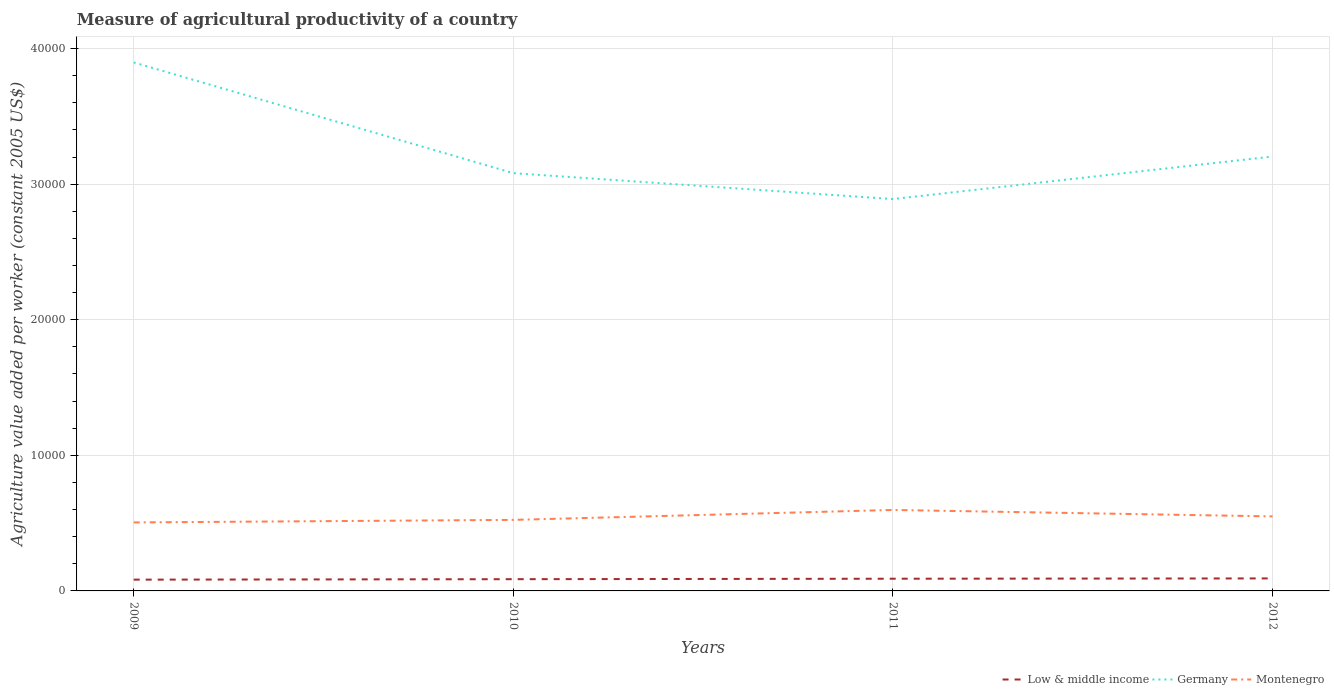How many different coloured lines are there?
Your answer should be compact. 3. Does the line corresponding to Montenegro intersect with the line corresponding to Low & middle income?
Ensure brevity in your answer.  No. Is the number of lines equal to the number of legend labels?
Your answer should be compact. Yes. Across all years, what is the maximum measure of agricultural productivity in Montenegro?
Offer a terse response. 5051.79. In which year was the measure of agricultural productivity in Germany maximum?
Keep it short and to the point. 2011. What is the total measure of agricultural productivity in Germany in the graph?
Ensure brevity in your answer.  -3137.17. What is the difference between the highest and the second highest measure of agricultural productivity in Montenegro?
Your answer should be compact. 919.67. How many years are there in the graph?
Your response must be concise. 4. What is the difference between two consecutive major ticks on the Y-axis?
Offer a terse response. 10000. Are the values on the major ticks of Y-axis written in scientific E-notation?
Offer a terse response. No. How are the legend labels stacked?
Your response must be concise. Horizontal. What is the title of the graph?
Offer a very short reply. Measure of agricultural productivity of a country. What is the label or title of the X-axis?
Ensure brevity in your answer.  Years. What is the label or title of the Y-axis?
Make the answer very short. Agriculture value added per worker (constant 2005 US$). What is the Agriculture value added per worker (constant 2005 US$) of Low & middle income in 2009?
Provide a succinct answer. 832.07. What is the Agriculture value added per worker (constant 2005 US$) of Germany in 2009?
Your answer should be compact. 3.90e+04. What is the Agriculture value added per worker (constant 2005 US$) in Montenegro in 2009?
Ensure brevity in your answer.  5051.79. What is the Agriculture value added per worker (constant 2005 US$) in Low & middle income in 2010?
Offer a terse response. 865.64. What is the Agriculture value added per worker (constant 2005 US$) in Germany in 2010?
Your answer should be very brief. 3.08e+04. What is the Agriculture value added per worker (constant 2005 US$) of Montenegro in 2010?
Give a very brief answer. 5239.42. What is the Agriculture value added per worker (constant 2005 US$) of Low & middle income in 2011?
Offer a terse response. 900.08. What is the Agriculture value added per worker (constant 2005 US$) of Germany in 2011?
Offer a terse response. 2.89e+04. What is the Agriculture value added per worker (constant 2005 US$) of Montenegro in 2011?
Provide a succinct answer. 5971.47. What is the Agriculture value added per worker (constant 2005 US$) in Low & middle income in 2012?
Your response must be concise. 922.36. What is the Agriculture value added per worker (constant 2005 US$) in Germany in 2012?
Offer a terse response. 3.20e+04. What is the Agriculture value added per worker (constant 2005 US$) of Montenegro in 2012?
Keep it short and to the point. 5496.22. Across all years, what is the maximum Agriculture value added per worker (constant 2005 US$) of Low & middle income?
Ensure brevity in your answer.  922.36. Across all years, what is the maximum Agriculture value added per worker (constant 2005 US$) in Germany?
Provide a succinct answer. 3.90e+04. Across all years, what is the maximum Agriculture value added per worker (constant 2005 US$) of Montenegro?
Your answer should be compact. 5971.47. Across all years, what is the minimum Agriculture value added per worker (constant 2005 US$) in Low & middle income?
Your answer should be very brief. 832.07. Across all years, what is the minimum Agriculture value added per worker (constant 2005 US$) of Germany?
Offer a very short reply. 2.89e+04. Across all years, what is the minimum Agriculture value added per worker (constant 2005 US$) of Montenegro?
Provide a short and direct response. 5051.79. What is the total Agriculture value added per worker (constant 2005 US$) of Low & middle income in the graph?
Give a very brief answer. 3520.15. What is the total Agriculture value added per worker (constant 2005 US$) of Germany in the graph?
Make the answer very short. 1.31e+05. What is the total Agriculture value added per worker (constant 2005 US$) in Montenegro in the graph?
Your response must be concise. 2.18e+04. What is the difference between the Agriculture value added per worker (constant 2005 US$) of Low & middle income in 2009 and that in 2010?
Your answer should be compact. -33.57. What is the difference between the Agriculture value added per worker (constant 2005 US$) in Germany in 2009 and that in 2010?
Offer a terse response. 8165.24. What is the difference between the Agriculture value added per worker (constant 2005 US$) in Montenegro in 2009 and that in 2010?
Your answer should be very brief. -187.63. What is the difference between the Agriculture value added per worker (constant 2005 US$) of Low & middle income in 2009 and that in 2011?
Ensure brevity in your answer.  -68.01. What is the difference between the Agriculture value added per worker (constant 2005 US$) in Germany in 2009 and that in 2011?
Provide a succinct answer. 1.01e+04. What is the difference between the Agriculture value added per worker (constant 2005 US$) of Montenegro in 2009 and that in 2011?
Give a very brief answer. -919.67. What is the difference between the Agriculture value added per worker (constant 2005 US$) in Low & middle income in 2009 and that in 2012?
Your response must be concise. -90.29. What is the difference between the Agriculture value added per worker (constant 2005 US$) of Germany in 2009 and that in 2012?
Offer a terse response. 6940.03. What is the difference between the Agriculture value added per worker (constant 2005 US$) of Montenegro in 2009 and that in 2012?
Ensure brevity in your answer.  -444.42. What is the difference between the Agriculture value added per worker (constant 2005 US$) of Low & middle income in 2010 and that in 2011?
Your answer should be compact. -34.44. What is the difference between the Agriculture value added per worker (constant 2005 US$) of Germany in 2010 and that in 2011?
Give a very brief answer. 1911.97. What is the difference between the Agriculture value added per worker (constant 2005 US$) in Montenegro in 2010 and that in 2011?
Provide a succinct answer. -732.05. What is the difference between the Agriculture value added per worker (constant 2005 US$) of Low & middle income in 2010 and that in 2012?
Your response must be concise. -56.72. What is the difference between the Agriculture value added per worker (constant 2005 US$) in Germany in 2010 and that in 2012?
Provide a succinct answer. -1225.21. What is the difference between the Agriculture value added per worker (constant 2005 US$) in Montenegro in 2010 and that in 2012?
Provide a short and direct response. -256.8. What is the difference between the Agriculture value added per worker (constant 2005 US$) in Low & middle income in 2011 and that in 2012?
Your answer should be compact. -22.28. What is the difference between the Agriculture value added per worker (constant 2005 US$) of Germany in 2011 and that in 2012?
Ensure brevity in your answer.  -3137.17. What is the difference between the Agriculture value added per worker (constant 2005 US$) of Montenegro in 2011 and that in 2012?
Give a very brief answer. 475.25. What is the difference between the Agriculture value added per worker (constant 2005 US$) in Low & middle income in 2009 and the Agriculture value added per worker (constant 2005 US$) in Germany in 2010?
Keep it short and to the point. -3.00e+04. What is the difference between the Agriculture value added per worker (constant 2005 US$) in Low & middle income in 2009 and the Agriculture value added per worker (constant 2005 US$) in Montenegro in 2010?
Make the answer very short. -4407.35. What is the difference between the Agriculture value added per worker (constant 2005 US$) in Germany in 2009 and the Agriculture value added per worker (constant 2005 US$) in Montenegro in 2010?
Make the answer very short. 3.37e+04. What is the difference between the Agriculture value added per worker (constant 2005 US$) of Low & middle income in 2009 and the Agriculture value added per worker (constant 2005 US$) of Germany in 2011?
Keep it short and to the point. -2.81e+04. What is the difference between the Agriculture value added per worker (constant 2005 US$) of Low & middle income in 2009 and the Agriculture value added per worker (constant 2005 US$) of Montenegro in 2011?
Provide a succinct answer. -5139.4. What is the difference between the Agriculture value added per worker (constant 2005 US$) of Germany in 2009 and the Agriculture value added per worker (constant 2005 US$) of Montenegro in 2011?
Offer a very short reply. 3.30e+04. What is the difference between the Agriculture value added per worker (constant 2005 US$) of Low & middle income in 2009 and the Agriculture value added per worker (constant 2005 US$) of Germany in 2012?
Provide a short and direct response. -3.12e+04. What is the difference between the Agriculture value added per worker (constant 2005 US$) of Low & middle income in 2009 and the Agriculture value added per worker (constant 2005 US$) of Montenegro in 2012?
Your answer should be very brief. -4664.15. What is the difference between the Agriculture value added per worker (constant 2005 US$) of Germany in 2009 and the Agriculture value added per worker (constant 2005 US$) of Montenegro in 2012?
Offer a terse response. 3.35e+04. What is the difference between the Agriculture value added per worker (constant 2005 US$) in Low & middle income in 2010 and the Agriculture value added per worker (constant 2005 US$) in Germany in 2011?
Offer a very short reply. -2.80e+04. What is the difference between the Agriculture value added per worker (constant 2005 US$) in Low & middle income in 2010 and the Agriculture value added per worker (constant 2005 US$) in Montenegro in 2011?
Make the answer very short. -5105.83. What is the difference between the Agriculture value added per worker (constant 2005 US$) of Germany in 2010 and the Agriculture value added per worker (constant 2005 US$) of Montenegro in 2011?
Keep it short and to the point. 2.48e+04. What is the difference between the Agriculture value added per worker (constant 2005 US$) in Low & middle income in 2010 and the Agriculture value added per worker (constant 2005 US$) in Germany in 2012?
Ensure brevity in your answer.  -3.12e+04. What is the difference between the Agriculture value added per worker (constant 2005 US$) in Low & middle income in 2010 and the Agriculture value added per worker (constant 2005 US$) in Montenegro in 2012?
Ensure brevity in your answer.  -4630.58. What is the difference between the Agriculture value added per worker (constant 2005 US$) of Germany in 2010 and the Agriculture value added per worker (constant 2005 US$) of Montenegro in 2012?
Your response must be concise. 2.53e+04. What is the difference between the Agriculture value added per worker (constant 2005 US$) in Low & middle income in 2011 and the Agriculture value added per worker (constant 2005 US$) in Germany in 2012?
Give a very brief answer. -3.11e+04. What is the difference between the Agriculture value added per worker (constant 2005 US$) of Low & middle income in 2011 and the Agriculture value added per worker (constant 2005 US$) of Montenegro in 2012?
Offer a terse response. -4596.13. What is the difference between the Agriculture value added per worker (constant 2005 US$) in Germany in 2011 and the Agriculture value added per worker (constant 2005 US$) in Montenegro in 2012?
Your response must be concise. 2.34e+04. What is the average Agriculture value added per worker (constant 2005 US$) of Low & middle income per year?
Provide a succinct answer. 880.04. What is the average Agriculture value added per worker (constant 2005 US$) in Germany per year?
Ensure brevity in your answer.  3.27e+04. What is the average Agriculture value added per worker (constant 2005 US$) of Montenegro per year?
Offer a terse response. 5439.72. In the year 2009, what is the difference between the Agriculture value added per worker (constant 2005 US$) of Low & middle income and Agriculture value added per worker (constant 2005 US$) of Germany?
Offer a terse response. -3.81e+04. In the year 2009, what is the difference between the Agriculture value added per worker (constant 2005 US$) in Low & middle income and Agriculture value added per worker (constant 2005 US$) in Montenegro?
Make the answer very short. -4219.72. In the year 2009, what is the difference between the Agriculture value added per worker (constant 2005 US$) in Germany and Agriculture value added per worker (constant 2005 US$) in Montenegro?
Your answer should be compact. 3.39e+04. In the year 2010, what is the difference between the Agriculture value added per worker (constant 2005 US$) of Low & middle income and Agriculture value added per worker (constant 2005 US$) of Germany?
Offer a terse response. -2.99e+04. In the year 2010, what is the difference between the Agriculture value added per worker (constant 2005 US$) in Low & middle income and Agriculture value added per worker (constant 2005 US$) in Montenegro?
Provide a short and direct response. -4373.78. In the year 2010, what is the difference between the Agriculture value added per worker (constant 2005 US$) in Germany and Agriculture value added per worker (constant 2005 US$) in Montenegro?
Ensure brevity in your answer.  2.56e+04. In the year 2011, what is the difference between the Agriculture value added per worker (constant 2005 US$) in Low & middle income and Agriculture value added per worker (constant 2005 US$) in Germany?
Your response must be concise. -2.80e+04. In the year 2011, what is the difference between the Agriculture value added per worker (constant 2005 US$) in Low & middle income and Agriculture value added per worker (constant 2005 US$) in Montenegro?
Ensure brevity in your answer.  -5071.38. In the year 2011, what is the difference between the Agriculture value added per worker (constant 2005 US$) in Germany and Agriculture value added per worker (constant 2005 US$) in Montenegro?
Provide a succinct answer. 2.29e+04. In the year 2012, what is the difference between the Agriculture value added per worker (constant 2005 US$) in Low & middle income and Agriculture value added per worker (constant 2005 US$) in Germany?
Make the answer very short. -3.11e+04. In the year 2012, what is the difference between the Agriculture value added per worker (constant 2005 US$) of Low & middle income and Agriculture value added per worker (constant 2005 US$) of Montenegro?
Your response must be concise. -4573.86. In the year 2012, what is the difference between the Agriculture value added per worker (constant 2005 US$) in Germany and Agriculture value added per worker (constant 2005 US$) in Montenegro?
Keep it short and to the point. 2.65e+04. What is the ratio of the Agriculture value added per worker (constant 2005 US$) of Low & middle income in 2009 to that in 2010?
Provide a succinct answer. 0.96. What is the ratio of the Agriculture value added per worker (constant 2005 US$) of Germany in 2009 to that in 2010?
Ensure brevity in your answer.  1.26. What is the ratio of the Agriculture value added per worker (constant 2005 US$) in Montenegro in 2009 to that in 2010?
Keep it short and to the point. 0.96. What is the ratio of the Agriculture value added per worker (constant 2005 US$) of Low & middle income in 2009 to that in 2011?
Your response must be concise. 0.92. What is the ratio of the Agriculture value added per worker (constant 2005 US$) of Germany in 2009 to that in 2011?
Your answer should be very brief. 1.35. What is the ratio of the Agriculture value added per worker (constant 2005 US$) in Montenegro in 2009 to that in 2011?
Your answer should be very brief. 0.85. What is the ratio of the Agriculture value added per worker (constant 2005 US$) in Low & middle income in 2009 to that in 2012?
Ensure brevity in your answer.  0.9. What is the ratio of the Agriculture value added per worker (constant 2005 US$) in Germany in 2009 to that in 2012?
Your answer should be very brief. 1.22. What is the ratio of the Agriculture value added per worker (constant 2005 US$) of Montenegro in 2009 to that in 2012?
Your answer should be very brief. 0.92. What is the ratio of the Agriculture value added per worker (constant 2005 US$) of Low & middle income in 2010 to that in 2011?
Keep it short and to the point. 0.96. What is the ratio of the Agriculture value added per worker (constant 2005 US$) of Germany in 2010 to that in 2011?
Give a very brief answer. 1.07. What is the ratio of the Agriculture value added per worker (constant 2005 US$) in Montenegro in 2010 to that in 2011?
Provide a succinct answer. 0.88. What is the ratio of the Agriculture value added per worker (constant 2005 US$) in Low & middle income in 2010 to that in 2012?
Provide a succinct answer. 0.94. What is the ratio of the Agriculture value added per worker (constant 2005 US$) of Germany in 2010 to that in 2012?
Ensure brevity in your answer.  0.96. What is the ratio of the Agriculture value added per worker (constant 2005 US$) of Montenegro in 2010 to that in 2012?
Make the answer very short. 0.95. What is the ratio of the Agriculture value added per worker (constant 2005 US$) of Low & middle income in 2011 to that in 2012?
Give a very brief answer. 0.98. What is the ratio of the Agriculture value added per worker (constant 2005 US$) of Germany in 2011 to that in 2012?
Give a very brief answer. 0.9. What is the ratio of the Agriculture value added per worker (constant 2005 US$) in Montenegro in 2011 to that in 2012?
Give a very brief answer. 1.09. What is the difference between the highest and the second highest Agriculture value added per worker (constant 2005 US$) of Low & middle income?
Make the answer very short. 22.28. What is the difference between the highest and the second highest Agriculture value added per worker (constant 2005 US$) in Germany?
Provide a short and direct response. 6940.03. What is the difference between the highest and the second highest Agriculture value added per worker (constant 2005 US$) of Montenegro?
Offer a terse response. 475.25. What is the difference between the highest and the lowest Agriculture value added per worker (constant 2005 US$) of Low & middle income?
Your answer should be very brief. 90.29. What is the difference between the highest and the lowest Agriculture value added per worker (constant 2005 US$) of Germany?
Keep it short and to the point. 1.01e+04. What is the difference between the highest and the lowest Agriculture value added per worker (constant 2005 US$) of Montenegro?
Offer a very short reply. 919.67. 